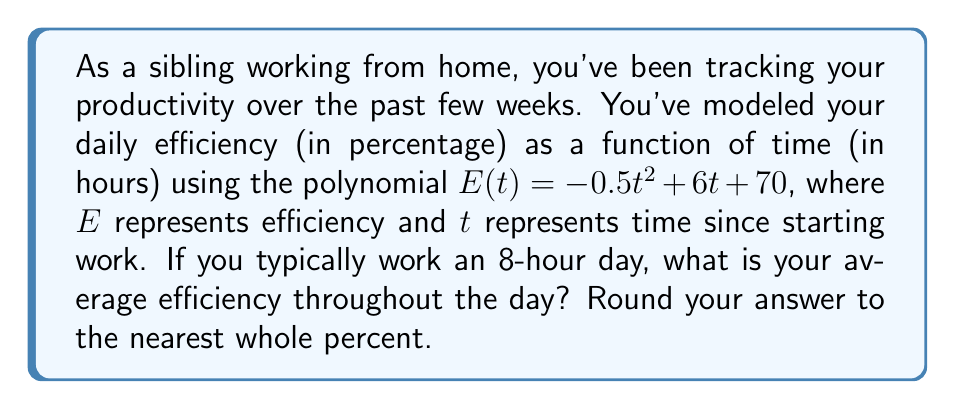Give your solution to this math problem. To solve this problem, we need to follow these steps:

1) The average efficiency over the workday is given by the definite integral of the efficiency function divided by the length of the workday:

   $$\text{Average Efficiency} = \frac{1}{8} \int_0^8 E(t) dt$$

2) Let's substitute our efficiency function:

   $$\frac{1}{8} \int_0^8 (-0.5t^2 + 6t + 70) dt$$

3) Now we integrate:

   $$\frac{1}{8} \left[-\frac{1}{6}t^3 + 3t^2 + 70t\right]_0^8$$

4) Evaluate the integral at the bounds:

   $$\frac{1}{8} \left(\left[-\frac{1}{6}(8^3) + 3(8^2) + 70(8)\right] - \left[-\frac{1}{6}(0^3) + 3(0^2) + 70(0)\right]\right)$$

5) Simplify:

   $$\frac{1}{8} \left(-\frac{512}{6} + 192 + 560\right) = \frac{1}{8} (752 - \frac{512}{6})$$

6) Calculate:

   $$\frac{1}{8} (752 - 85.33) = \frac{666.67}{8} = 83.33$$

7) Rounding to the nearest whole percent:

   83%
Answer: 83% 